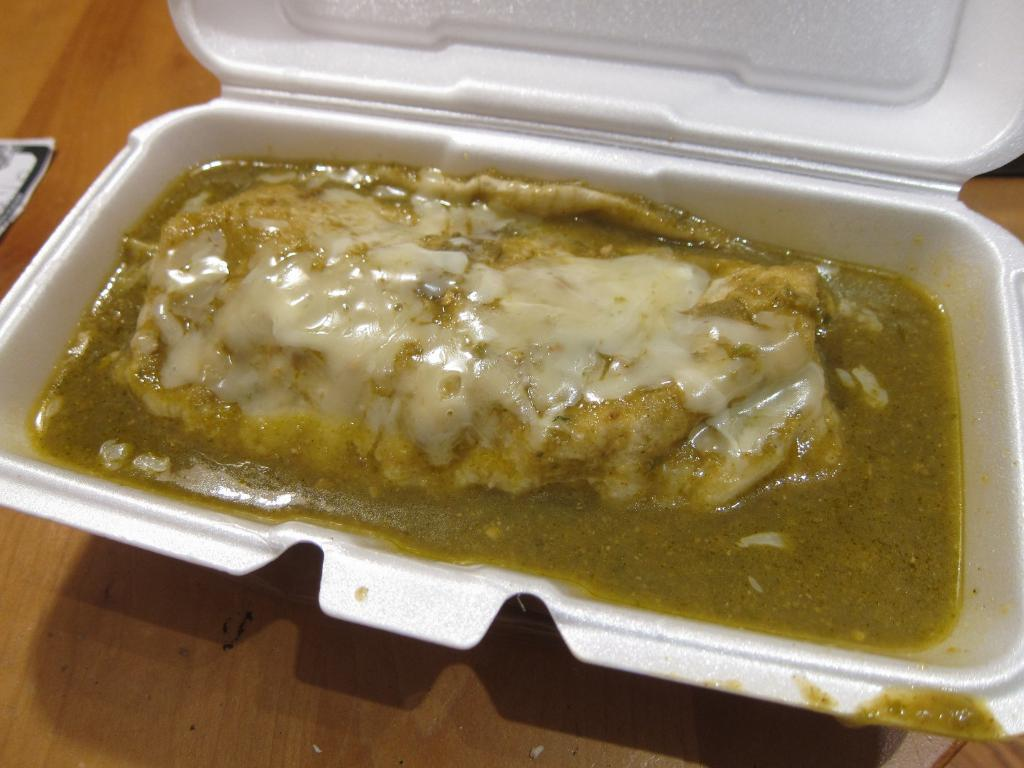What is the main subject in the foreground of the image? There is a food item in a cup-like object with a lid in the foreground of the image. What is the surface on which the cup-like object is placed? The cup-like object is on a wooden surface. Can you describe the object on the left side of the image? Unfortunately, the provided facts do not mention any object on the left side of the image. What type of pleasure can be seen on the back of the chain in the image? There is no chain or pleasure present in the image; it features a food item in a cup-like object with a lid on a wooden surface. 